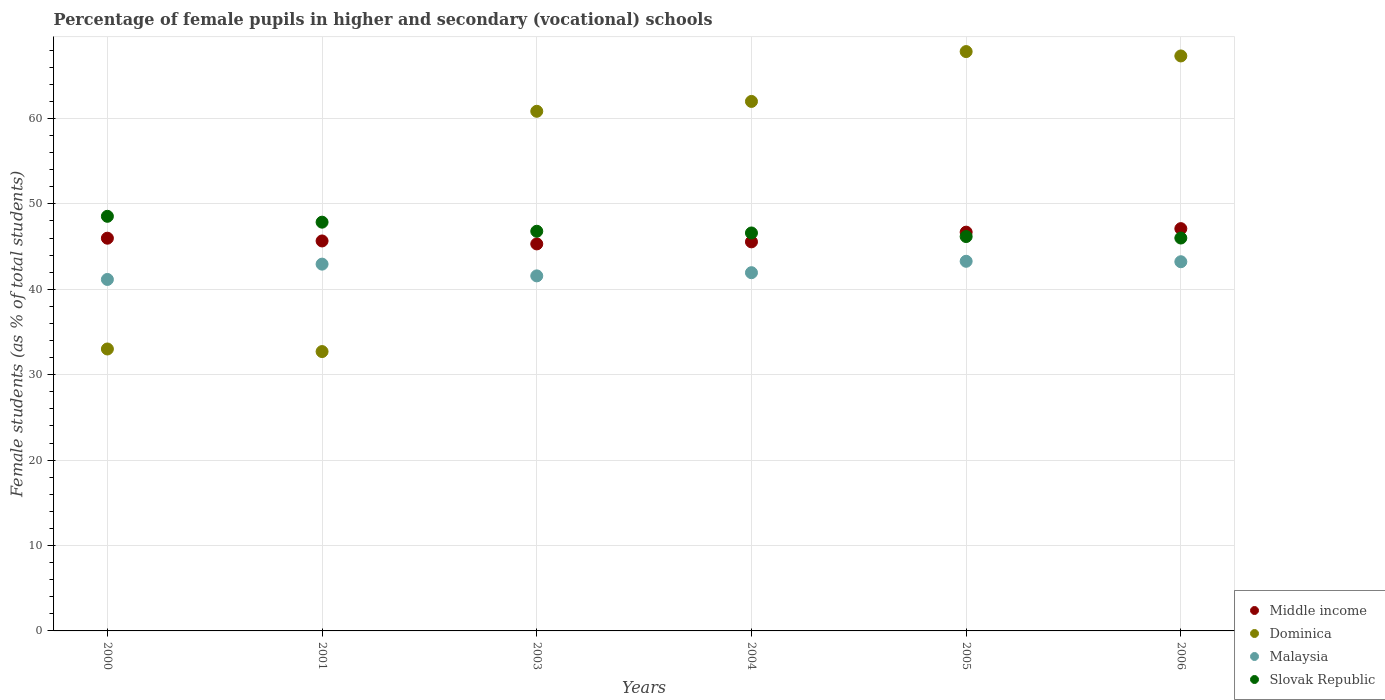How many different coloured dotlines are there?
Offer a very short reply. 4. Is the number of dotlines equal to the number of legend labels?
Your answer should be very brief. Yes. What is the percentage of female pupils in higher and secondary schools in Dominica in 2005?
Your answer should be compact. 67.83. Across all years, what is the maximum percentage of female pupils in higher and secondary schools in Slovak Republic?
Your answer should be compact. 48.54. Across all years, what is the minimum percentage of female pupils in higher and secondary schools in Slovak Republic?
Offer a terse response. 46. What is the total percentage of female pupils in higher and secondary schools in Dominica in the graph?
Your answer should be compact. 323.69. What is the difference between the percentage of female pupils in higher and secondary schools in Middle income in 2000 and that in 2003?
Your response must be concise. 0.67. What is the difference between the percentage of female pupils in higher and secondary schools in Slovak Republic in 2006 and the percentage of female pupils in higher and secondary schools in Malaysia in 2004?
Provide a short and direct response. 4.06. What is the average percentage of female pupils in higher and secondary schools in Middle income per year?
Your answer should be very brief. 46.05. In the year 2000, what is the difference between the percentage of female pupils in higher and secondary schools in Middle income and percentage of female pupils in higher and secondary schools in Malaysia?
Offer a terse response. 4.83. In how many years, is the percentage of female pupils in higher and secondary schools in Middle income greater than 66 %?
Your answer should be compact. 0. What is the ratio of the percentage of female pupils in higher and secondary schools in Dominica in 2005 to that in 2006?
Offer a very short reply. 1.01. Is the percentage of female pupils in higher and secondary schools in Middle income in 2001 less than that in 2003?
Offer a very short reply. No. Is the difference between the percentage of female pupils in higher and secondary schools in Middle income in 2003 and 2004 greater than the difference between the percentage of female pupils in higher and secondary schools in Malaysia in 2003 and 2004?
Your response must be concise. Yes. What is the difference between the highest and the second highest percentage of female pupils in higher and secondary schools in Dominica?
Your response must be concise. 0.51. What is the difference between the highest and the lowest percentage of female pupils in higher and secondary schools in Dominica?
Ensure brevity in your answer.  35.12. In how many years, is the percentage of female pupils in higher and secondary schools in Slovak Republic greater than the average percentage of female pupils in higher and secondary schools in Slovak Republic taken over all years?
Make the answer very short. 2. Is the percentage of female pupils in higher and secondary schools in Middle income strictly greater than the percentage of female pupils in higher and secondary schools in Slovak Republic over the years?
Offer a terse response. No. Is the percentage of female pupils in higher and secondary schools in Dominica strictly less than the percentage of female pupils in higher and secondary schools in Middle income over the years?
Your response must be concise. No. What is the difference between two consecutive major ticks on the Y-axis?
Give a very brief answer. 10. Are the values on the major ticks of Y-axis written in scientific E-notation?
Your answer should be compact. No. Does the graph contain any zero values?
Ensure brevity in your answer.  No. How are the legend labels stacked?
Your answer should be very brief. Vertical. What is the title of the graph?
Your response must be concise. Percentage of female pupils in higher and secondary (vocational) schools. What is the label or title of the Y-axis?
Offer a terse response. Female students (as % of total students). What is the Female students (as % of total students) in Middle income in 2000?
Ensure brevity in your answer.  45.98. What is the Female students (as % of total students) of Dominica in 2000?
Your answer should be compact. 33.01. What is the Female students (as % of total students) in Malaysia in 2000?
Give a very brief answer. 41.15. What is the Female students (as % of total students) of Slovak Republic in 2000?
Keep it short and to the point. 48.54. What is the Female students (as % of total students) of Middle income in 2001?
Your answer should be compact. 45.66. What is the Female students (as % of total students) of Dominica in 2001?
Ensure brevity in your answer.  32.71. What is the Female students (as % of total students) in Malaysia in 2001?
Provide a short and direct response. 42.94. What is the Female students (as % of total students) in Slovak Republic in 2001?
Provide a short and direct response. 47.86. What is the Female students (as % of total students) in Middle income in 2003?
Provide a short and direct response. 45.31. What is the Female students (as % of total students) in Dominica in 2003?
Provide a short and direct response. 60.84. What is the Female students (as % of total students) in Malaysia in 2003?
Offer a terse response. 41.57. What is the Female students (as % of total students) of Slovak Republic in 2003?
Your answer should be compact. 46.79. What is the Female students (as % of total students) in Middle income in 2004?
Offer a terse response. 45.55. What is the Female students (as % of total students) of Dominica in 2004?
Your answer should be very brief. 61.99. What is the Female students (as % of total students) in Malaysia in 2004?
Your answer should be very brief. 41.94. What is the Female students (as % of total students) in Slovak Republic in 2004?
Provide a short and direct response. 46.59. What is the Female students (as % of total students) of Middle income in 2005?
Keep it short and to the point. 46.69. What is the Female students (as % of total students) in Dominica in 2005?
Give a very brief answer. 67.83. What is the Female students (as % of total students) in Malaysia in 2005?
Provide a succinct answer. 43.28. What is the Female students (as % of total students) of Slovak Republic in 2005?
Provide a short and direct response. 46.17. What is the Female students (as % of total students) of Middle income in 2006?
Provide a short and direct response. 47.1. What is the Female students (as % of total students) in Dominica in 2006?
Provide a succinct answer. 67.32. What is the Female students (as % of total students) of Malaysia in 2006?
Provide a succinct answer. 43.22. What is the Female students (as % of total students) of Slovak Republic in 2006?
Give a very brief answer. 46. Across all years, what is the maximum Female students (as % of total students) of Middle income?
Provide a short and direct response. 47.1. Across all years, what is the maximum Female students (as % of total students) in Dominica?
Give a very brief answer. 67.83. Across all years, what is the maximum Female students (as % of total students) in Malaysia?
Your answer should be compact. 43.28. Across all years, what is the maximum Female students (as % of total students) in Slovak Republic?
Your response must be concise. 48.54. Across all years, what is the minimum Female students (as % of total students) of Middle income?
Offer a very short reply. 45.31. Across all years, what is the minimum Female students (as % of total students) in Dominica?
Give a very brief answer. 32.71. Across all years, what is the minimum Female students (as % of total students) in Malaysia?
Offer a very short reply. 41.15. Across all years, what is the minimum Female students (as % of total students) of Slovak Republic?
Make the answer very short. 46. What is the total Female students (as % of total students) of Middle income in the graph?
Keep it short and to the point. 276.29. What is the total Female students (as % of total students) in Dominica in the graph?
Your answer should be compact. 323.69. What is the total Female students (as % of total students) of Malaysia in the graph?
Make the answer very short. 254.1. What is the total Female students (as % of total students) of Slovak Republic in the graph?
Offer a terse response. 281.95. What is the difference between the Female students (as % of total students) of Middle income in 2000 and that in 2001?
Ensure brevity in your answer.  0.32. What is the difference between the Female students (as % of total students) of Dominica in 2000 and that in 2001?
Your answer should be compact. 0.3. What is the difference between the Female students (as % of total students) in Malaysia in 2000 and that in 2001?
Make the answer very short. -1.79. What is the difference between the Female students (as % of total students) of Slovak Republic in 2000 and that in 2001?
Make the answer very short. 0.69. What is the difference between the Female students (as % of total students) in Middle income in 2000 and that in 2003?
Give a very brief answer. 0.67. What is the difference between the Female students (as % of total students) of Dominica in 2000 and that in 2003?
Provide a succinct answer. -27.83. What is the difference between the Female students (as % of total students) of Malaysia in 2000 and that in 2003?
Ensure brevity in your answer.  -0.42. What is the difference between the Female students (as % of total students) of Slovak Republic in 2000 and that in 2003?
Provide a succinct answer. 1.75. What is the difference between the Female students (as % of total students) of Middle income in 2000 and that in 2004?
Make the answer very short. 0.43. What is the difference between the Female students (as % of total students) in Dominica in 2000 and that in 2004?
Make the answer very short. -28.98. What is the difference between the Female students (as % of total students) in Malaysia in 2000 and that in 2004?
Offer a very short reply. -0.79. What is the difference between the Female students (as % of total students) of Slovak Republic in 2000 and that in 2004?
Offer a terse response. 1.95. What is the difference between the Female students (as % of total students) in Middle income in 2000 and that in 2005?
Your response must be concise. -0.71. What is the difference between the Female students (as % of total students) of Dominica in 2000 and that in 2005?
Ensure brevity in your answer.  -34.82. What is the difference between the Female students (as % of total students) in Malaysia in 2000 and that in 2005?
Provide a succinct answer. -2.13. What is the difference between the Female students (as % of total students) of Slovak Republic in 2000 and that in 2005?
Your answer should be compact. 2.37. What is the difference between the Female students (as % of total students) of Middle income in 2000 and that in 2006?
Give a very brief answer. -1.12. What is the difference between the Female students (as % of total students) in Dominica in 2000 and that in 2006?
Offer a very short reply. -34.31. What is the difference between the Female students (as % of total students) in Malaysia in 2000 and that in 2006?
Offer a very short reply. -2.07. What is the difference between the Female students (as % of total students) in Slovak Republic in 2000 and that in 2006?
Offer a terse response. 2.54. What is the difference between the Female students (as % of total students) in Middle income in 2001 and that in 2003?
Provide a succinct answer. 0.35. What is the difference between the Female students (as % of total students) in Dominica in 2001 and that in 2003?
Offer a terse response. -28.13. What is the difference between the Female students (as % of total students) in Malaysia in 2001 and that in 2003?
Offer a terse response. 1.38. What is the difference between the Female students (as % of total students) in Slovak Republic in 2001 and that in 2003?
Provide a short and direct response. 1.06. What is the difference between the Female students (as % of total students) in Middle income in 2001 and that in 2004?
Provide a succinct answer. 0.11. What is the difference between the Female students (as % of total students) of Dominica in 2001 and that in 2004?
Ensure brevity in your answer.  -29.29. What is the difference between the Female students (as % of total students) in Malaysia in 2001 and that in 2004?
Your answer should be very brief. 1. What is the difference between the Female students (as % of total students) in Slovak Republic in 2001 and that in 2004?
Provide a short and direct response. 1.26. What is the difference between the Female students (as % of total students) of Middle income in 2001 and that in 2005?
Your response must be concise. -1.03. What is the difference between the Female students (as % of total students) of Dominica in 2001 and that in 2005?
Offer a terse response. -35.12. What is the difference between the Female students (as % of total students) in Malaysia in 2001 and that in 2005?
Your answer should be very brief. -0.33. What is the difference between the Female students (as % of total students) of Slovak Republic in 2001 and that in 2005?
Ensure brevity in your answer.  1.68. What is the difference between the Female students (as % of total students) of Middle income in 2001 and that in 2006?
Offer a very short reply. -1.44. What is the difference between the Female students (as % of total students) of Dominica in 2001 and that in 2006?
Give a very brief answer. -34.61. What is the difference between the Female students (as % of total students) in Malaysia in 2001 and that in 2006?
Offer a terse response. -0.28. What is the difference between the Female students (as % of total students) in Slovak Republic in 2001 and that in 2006?
Your answer should be compact. 1.86. What is the difference between the Female students (as % of total students) in Middle income in 2003 and that in 2004?
Keep it short and to the point. -0.24. What is the difference between the Female students (as % of total students) of Dominica in 2003 and that in 2004?
Make the answer very short. -1.16. What is the difference between the Female students (as % of total students) in Malaysia in 2003 and that in 2004?
Make the answer very short. -0.37. What is the difference between the Female students (as % of total students) of Slovak Republic in 2003 and that in 2004?
Your answer should be compact. 0.2. What is the difference between the Female students (as % of total students) in Middle income in 2003 and that in 2005?
Offer a very short reply. -1.38. What is the difference between the Female students (as % of total students) in Dominica in 2003 and that in 2005?
Provide a succinct answer. -6.99. What is the difference between the Female students (as % of total students) of Malaysia in 2003 and that in 2005?
Offer a very short reply. -1.71. What is the difference between the Female students (as % of total students) of Slovak Republic in 2003 and that in 2005?
Ensure brevity in your answer.  0.62. What is the difference between the Female students (as % of total students) in Middle income in 2003 and that in 2006?
Keep it short and to the point. -1.79. What is the difference between the Female students (as % of total students) in Dominica in 2003 and that in 2006?
Provide a succinct answer. -6.48. What is the difference between the Female students (as % of total students) in Malaysia in 2003 and that in 2006?
Offer a terse response. -1.66. What is the difference between the Female students (as % of total students) of Slovak Republic in 2003 and that in 2006?
Ensure brevity in your answer.  0.79. What is the difference between the Female students (as % of total students) in Middle income in 2004 and that in 2005?
Provide a short and direct response. -1.14. What is the difference between the Female students (as % of total students) in Dominica in 2004 and that in 2005?
Provide a short and direct response. -5.84. What is the difference between the Female students (as % of total students) of Malaysia in 2004 and that in 2005?
Provide a succinct answer. -1.34. What is the difference between the Female students (as % of total students) of Slovak Republic in 2004 and that in 2005?
Your answer should be very brief. 0.42. What is the difference between the Female students (as % of total students) of Middle income in 2004 and that in 2006?
Your answer should be compact. -1.55. What is the difference between the Female students (as % of total students) of Dominica in 2004 and that in 2006?
Provide a succinct answer. -5.32. What is the difference between the Female students (as % of total students) of Malaysia in 2004 and that in 2006?
Offer a terse response. -1.28. What is the difference between the Female students (as % of total students) in Slovak Republic in 2004 and that in 2006?
Your answer should be very brief. 0.59. What is the difference between the Female students (as % of total students) of Middle income in 2005 and that in 2006?
Provide a short and direct response. -0.41. What is the difference between the Female students (as % of total students) in Dominica in 2005 and that in 2006?
Make the answer very short. 0.51. What is the difference between the Female students (as % of total students) in Malaysia in 2005 and that in 2006?
Your answer should be very brief. 0.05. What is the difference between the Female students (as % of total students) of Slovak Republic in 2005 and that in 2006?
Your answer should be very brief. 0.17. What is the difference between the Female students (as % of total students) of Middle income in 2000 and the Female students (as % of total students) of Dominica in 2001?
Provide a short and direct response. 13.27. What is the difference between the Female students (as % of total students) in Middle income in 2000 and the Female students (as % of total students) in Malaysia in 2001?
Your answer should be very brief. 3.04. What is the difference between the Female students (as % of total students) in Middle income in 2000 and the Female students (as % of total students) in Slovak Republic in 2001?
Your response must be concise. -1.88. What is the difference between the Female students (as % of total students) of Dominica in 2000 and the Female students (as % of total students) of Malaysia in 2001?
Offer a terse response. -9.93. What is the difference between the Female students (as % of total students) in Dominica in 2000 and the Female students (as % of total students) in Slovak Republic in 2001?
Offer a terse response. -14.85. What is the difference between the Female students (as % of total students) in Malaysia in 2000 and the Female students (as % of total students) in Slovak Republic in 2001?
Your response must be concise. -6.71. What is the difference between the Female students (as % of total students) of Middle income in 2000 and the Female students (as % of total students) of Dominica in 2003?
Give a very brief answer. -14.86. What is the difference between the Female students (as % of total students) of Middle income in 2000 and the Female students (as % of total students) of Malaysia in 2003?
Offer a very short reply. 4.41. What is the difference between the Female students (as % of total students) of Middle income in 2000 and the Female students (as % of total students) of Slovak Republic in 2003?
Provide a succinct answer. -0.81. What is the difference between the Female students (as % of total students) of Dominica in 2000 and the Female students (as % of total students) of Malaysia in 2003?
Ensure brevity in your answer.  -8.56. What is the difference between the Female students (as % of total students) of Dominica in 2000 and the Female students (as % of total students) of Slovak Republic in 2003?
Ensure brevity in your answer.  -13.78. What is the difference between the Female students (as % of total students) in Malaysia in 2000 and the Female students (as % of total students) in Slovak Republic in 2003?
Your answer should be very brief. -5.64. What is the difference between the Female students (as % of total students) of Middle income in 2000 and the Female students (as % of total students) of Dominica in 2004?
Keep it short and to the point. -16.01. What is the difference between the Female students (as % of total students) in Middle income in 2000 and the Female students (as % of total students) in Malaysia in 2004?
Your response must be concise. 4.04. What is the difference between the Female students (as % of total students) of Middle income in 2000 and the Female students (as % of total students) of Slovak Republic in 2004?
Make the answer very short. -0.61. What is the difference between the Female students (as % of total students) in Dominica in 2000 and the Female students (as % of total students) in Malaysia in 2004?
Your response must be concise. -8.93. What is the difference between the Female students (as % of total students) in Dominica in 2000 and the Female students (as % of total students) in Slovak Republic in 2004?
Give a very brief answer. -13.58. What is the difference between the Female students (as % of total students) in Malaysia in 2000 and the Female students (as % of total students) in Slovak Republic in 2004?
Provide a short and direct response. -5.44. What is the difference between the Female students (as % of total students) of Middle income in 2000 and the Female students (as % of total students) of Dominica in 2005?
Your answer should be compact. -21.85. What is the difference between the Female students (as % of total students) of Middle income in 2000 and the Female students (as % of total students) of Malaysia in 2005?
Keep it short and to the point. 2.7. What is the difference between the Female students (as % of total students) of Middle income in 2000 and the Female students (as % of total students) of Slovak Republic in 2005?
Give a very brief answer. -0.19. What is the difference between the Female students (as % of total students) in Dominica in 2000 and the Female students (as % of total students) in Malaysia in 2005?
Your response must be concise. -10.27. What is the difference between the Female students (as % of total students) in Dominica in 2000 and the Female students (as % of total students) in Slovak Republic in 2005?
Offer a terse response. -13.16. What is the difference between the Female students (as % of total students) in Malaysia in 2000 and the Female students (as % of total students) in Slovak Republic in 2005?
Provide a succinct answer. -5.02. What is the difference between the Female students (as % of total students) in Middle income in 2000 and the Female students (as % of total students) in Dominica in 2006?
Keep it short and to the point. -21.34. What is the difference between the Female students (as % of total students) in Middle income in 2000 and the Female students (as % of total students) in Malaysia in 2006?
Your answer should be compact. 2.76. What is the difference between the Female students (as % of total students) in Middle income in 2000 and the Female students (as % of total students) in Slovak Republic in 2006?
Your answer should be very brief. -0.02. What is the difference between the Female students (as % of total students) in Dominica in 2000 and the Female students (as % of total students) in Malaysia in 2006?
Offer a very short reply. -10.22. What is the difference between the Female students (as % of total students) in Dominica in 2000 and the Female students (as % of total students) in Slovak Republic in 2006?
Ensure brevity in your answer.  -12.99. What is the difference between the Female students (as % of total students) in Malaysia in 2000 and the Female students (as % of total students) in Slovak Republic in 2006?
Give a very brief answer. -4.85. What is the difference between the Female students (as % of total students) of Middle income in 2001 and the Female students (as % of total students) of Dominica in 2003?
Provide a succinct answer. -15.18. What is the difference between the Female students (as % of total students) in Middle income in 2001 and the Female students (as % of total students) in Malaysia in 2003?
Offer a very short reply. 4.09. What is the difference between the Female students (as % of total students) of Middle income in 2001 and the Female students (as % of total students) of Slovak Republic in 2003?
Provide a succinct answer. -1.14. What is the difference between the Female students (as % of total students) in Dominica in 2001 and the Female students (as % of total students) in Malaysia in 2003?
Ensure brevity in your answer.  -8.86. What is the difference between the Female students (as % of total students) in Dominica in 2001 and the Female students (as % of total students) in Slovak Republic in 2003?
Offer a very short reply. -14.09. What is the difference between the Female students (as % of total students) in Malaysia in 2001 and the Female students (as % of total students) in Slovak Republic in 2003?
Ensure brevity in your answer.  -3.85. What is the difference between the Female students (as % of total students) in Middle income in 2001 and the Female students (as % of total students) in Dominica in 2004?
Keep it short and to the point. -16.34. What is the difference between the Female students (as % of total students) of Middle income in 2001 and the Female students (as % of total students) of Malaysia in 2004?
Your response must be concise. 3.72. What is the difference between the Female students (as % of total students) in Middle income in 2001 and the Female students (as % of total students) in Slovak Republic in 2004?
Keep it short and to the point. -0.94. What is the difference between the Female students (as % of total students) of Dominica in 2001 and the Female students (as % of total students) of Malaysia in 2004?
Offer a terse response. -9.23. What is the difference between the Female students (as % of total students) in Dominica in 2001 and the Female students (as % of total students) in Slovak Republic in 2004?
Provide a short and direct response. -13.89. What is the difference between the Female students (as % of total students) of Malaysia in 2001 and the Female students (as % of total students) of Slovak Republic in 2004?
Your answer should be compact. -3.65. What is the difference between the Female students (as % of total students) of Middle income in 2001 and the Female students (as % of total students) of Dominica in 2005?
Your answer should be compact. -22.17. What is the difference between the Female students (as % of total students) of Middle income in 2001 and the Female students (as % of total students) of Malaysia in 2005?
Your answer should be very brief. 2.38. What is the difference between the Female students (as % of total students) of Middle income in 2001 and the Female students (as % of total students) of Slovak Republic in 2005?
Keep it short and to the point. -0.51. What is the difference between the Female students (as % of total students) in Dominica in 2001 and the Female students (as % of total students) in Malaysia in 2005?
Your response must be concise. -10.57. What is the difference between the Female students (as % of total students) of Dominica in 2001 and the Female students (as % of total students) of Slovak Republic in 2005?
Keep it short and to the point. -13.47. What is the difference between the Female students (as % of total students) of Malaysia in 2001 and the Female students (as % of total students) of Slovak Republic in 2005?
Offer a terse response. -3.23. What is the difference between the Female students (as % of total students) of Middle income in 2001 and the Female students (as % of total students) of Dominica in 2006?
Provide a succinct answer. -21.66. What is the difference between the Female students (as % of total students) of Middle income in 2001 and the Female students (as % of total students) of Malaysia in 2006?
Provide a short and direct response. 2.43. What is the difference between the Female students (as % of total students) in Middle income in 2001 and the Female students (as % of total students) in Slovak Republic in 2006?
Give a very brief answer. -0.34. What is the difference between the Female students (as % of total students) of Dominica in 2001 and the Female students (as % of total students) of Malaysia in 2006?
Offer a very short reply. -10.52. What is the difference between the Female students (as % of total students) in Dominica in 2001 and the Female students (as % of total students) in Slovak Republic in 2006?
Make the answer very short. -13.29. What is the difference between the Female students (as % of total students) in Malaysia in 2001 and the Female students (as % of total students) in Slovak Republic in 2006?
Offer a very short reply. -3.06. What is the difference between the Female students (as % of total students) in Middle income in 2003 and the Female students (as % of total students) in Dominica in 2004?
Your answer should be very brief. -16.68. What is the difference between the Female students (as % of total students) of Middle income in 2003 and the Female students (as % of total students) of Malaysia in 2004?
Provide a short and direct response. 3.37. What is the difference between the Female students (as % of total students) in Middle income in 2003 and the Female students (as % of total students) in Slovak Republic in 2004?
Offer a very short reply. -1.28. What is the difference between the Female students (as % of total students) of Dominica in 2003 and the Female students (as % of total students) of Malaysia in 2004?
Make the answer very short. 18.9. What is the difference between the Female students (as % of total students) of Dominica in 2003 and the Female students (as % of total students) of Slovak Republic in 2004?
Make the answer very short. 14.25. What is the difference between the Female students (as % of total students) of Malaysia in 2003 and the Female students (as % of total students) of Slovak Republic in 2004?
Offer a very short reply. -5.02. What is the difference between the Female students (as % of total students) of Middle income in 2003 and the Female students (as % of total students) of Dominica in 2005?
Offer a very short reply. -22.52. What is the difference between the Female students (as % of total students) in Middle income in 2003 and the Female students (as % of total students) in Malaysia in 2005?
Offer a very short reply. 2.03. What is the difference between the Female students (as % of total students) of Middle income in 2003 and the Female students (as % of total students) of Slovak Republic in 2005?
Keep it short and to the point. -0.86. What is the difference between the Female students (as % of total students) of Dominica in 2003 and the Female students (as % of total students) of Malaysia in 2005?
Make the answer very short. 17.56. What is the difference between the Female students (as % of total students) of Dominica in 2003 and the Female students (as % of total students) of Slovak Republic in 2005?
Ensure brevity in your answer.  14.67. What is the difference between the Female students (as % of total students) of Malaysia in 2003 and the Female students (as % of total students) of Slovak Republic in 2005?
Your answer should be compact. -4.6. What is the difference between the Female students (as % of total students) in Middle income in 2003 and the Female students (as % of total students) in Dominica in 2006?
Provide a short and direct response. -22.01. What is the difference between the Female students (as % of total students) of Middle income in 2003 and the Female students (as % of total students) of Malaysia in 2006?
Make the answer very short. 2.09. What is the difference between the Female students (as % of total students) in Middle income in 2003 and the Female students (as % of total students) in Slovak Republic in 2006?
Provide a short and direct response. -0.69. What is the difference between the Female students (as % of total students) in Dominica in 2003 and the Female students (as % of total students) in Malaysia in 2006?
Ensure brevity in your answer.  17.61. What is the difference between the Female students (as % of total students) in Dominica in 2003 and the Female students (as % of total students) in Slovak Republic in 2006?
Your answer should be compact. 14.84. What is the difference between the Female students (as % of total students) in Malaysia in 2003 and the Female students (as % of total students) in Slovak Republic in 2006?
Ensure brevity in your answer.  -4.43. What is the difference between the Female students (as % of total students) in Middle income in 2004 and the Female students (as % of total students) in Dominica in 2005?
Make the answer very short. -22.28. What is the difference between the Female students (as % of total students) of Middle income in 2004 and the Female students (as % of total students) of Malaysia in 2005?
Give a very brief answer. 2.27. What is the difference between the Female students (as % of total students) of Middle income in 2004 and the Female students (as % of total students) of Slovak Republic in 2005?
Offer a terse response. -0.62. What is the difference between the Female students (as % of total students) of Dominica in 2004 and the Female students (as % of total students) of Malaysia in 2005?
Make the answer very short. 18.72. What is the difference between the Female students (as % of total students) in Dominica in 2004 and the Female students (as % of total students) in Slovak Republic in 2005?
Provide a succinct answer. 15.82. What is the difference between the Female students (as % of total students) of Malaysia in 2004 and the Female students (as % of total students) of Slovak Republic in 2005?
Make the answer very short. -4.23. What is the difference between the Female students (as % of total students) of Middle income in 2004 and the Female students (as % of total students) of Dominica in 2006?
Provide a short and direct response. -21.77. What is the difference between the Female students (as % of total students) in Middle income in 2004 and the Female students (as % of total students) in Malaysia in 2006?
Provide a succinct answer. 2.33. What is the difference between the Female students (as % of total students) of Middle income in 2004 and the Female students (as % of total students) of Slovak Republic in 2006?
Your response must be concise. -0.45. What is the difference between the Female students (as % of total students) of Dominica in 2004 and the Female students (as % of total students) of Malaysia in 2006?
Ensure brevity in your answer.  18.77. What is the difference between the Female students (as % of total students) in Dominica in 2004 and the Female students (as % of total students) in Slovak Republic in 2006?
Keep it short and to the point. 15.99. What is the difference between the Female students (as % of total students) in Malaysia in 2004 and the Female students (as % of total students) in Slovak Republic in 2006?
Your answer should be very brief. -4.06. What is the difference between the Female students (as % of total students) of Middle income in 2005 and the Female students (as % of total students) of Dominica in 2006?
Give a very brief answer. -20.63. What is the difference between the Female students (as % of total students) of Middle income in 2005 and the Female students (as % of total students) of Malaysia in 2006?
Your answer should be very brief. 3.46. What is the difference between the Female students (as % of total students) in Middle income in 2005 and the Female students (as % of total students) in Slovak Republic in 2006?
Provide a short and direct response. 0.69. What is the difference between the Female students (as % of total students) of Dominica in 2005 and the Female students (as % of total students) of Malaysia in 2006?
Make the answer very short. 24.61. What is the difference between the Female students (as % of total students) of Dominica in 2005 and the Female students (as % of total students) of Slovak Republic in 2006?
Offer a very short reply. 21.83. What is the difference between the Female students (as % of total students) in Malaysia in 2005 and the Female students (as % of total students) in Slovak Republic in 2006?
Ensure brevity in your answer.  -2.72. What is the average Female students (as % of total students) of Middle income per year?
Provide a short and direct response. 46.05. What is the average Female students (as % of total students) in Dominica per year?
Offer a very short reply. 53.95. What is the average Female students (as % of total students) in Malaysia per year?
Give a very brief answer. 42.35. What is the average Female students (as % of total students) of Slovak Republic per year?
Ensure brevity in your answer.  46.99. In the year 2000, what is the difference between the Female students (as % of total students) in Middle income and Female students (as % of total students) in Dominica?
Provide a succinct answer. 12.97. In the year 2000, what is the difference between the Female students (as % of total students) in Middle income and Female students (as % of total students) in Malaysia?
Make the answer very short. 4.83. In the year 2000, what is the difference between the Female students (as % of total students) in Middle income and Female students (as % of total students) in Slovak Republic?
Provide a succinct answer. -2.56. In the year 2000, what is the difference between the Female students (as % of total students) of Dominica and Female students (as % of total students) of Malaysia?
Provide a succinct answer. -8.14. In the year 2000, what is the difference between the Female students (as % of total students) in Dominica and Female students (as % of total students) in Slovak Republic?
Provide a succinct answer. -15.53. In the year 2000, what is the difference between the Female students (as % of total students) in Malaysia and Female students (as % of total students) in Slovak Republic?
Provide a succinct answer. -7.39. In the year 2001, what is the difference between the Female students (as % of total students) of Middle income and Female students (as % of total students) of Dominica?
Your answer should be very brief. 12.95. In the year 2001, what is the difference between the Female students (as % of total students) in Middle income and Female students (as % of total students) in Malaysia?
Provide a succinct answer. 2.71. In the year 2001, what is the difference between the Female students (as % of total students) in Middle income and Female students (as % of total students) in Slovak Republic?
Offer a very short reply. -2.2. In the year 2001, what is the difference between the Female students (as % of total students) of Dominica and Female students (as % of total students) of Malaysia?
Offer a very short reply. -10.24. In the year 2001, what is the difference between the Female students (as % of total students) in Dominica and Female students (as % of total students) in Slovak Republic?
Keep it short and to the point. -15.15. In the year 2001, what is the difference between the Female students (as % of total students) in Malaysia and Female students (as % of total students) in Slovak Republic?
Keep it short and to the point. -4.91. In the year 2003, what is the difference between the Female students (as % of total students) in Middle income and Female students (as % of total students) in Dominica?
Provide a succinct answer. -15.53. In the year 2003, what is the difference between the Female students (as % of total students) of Middle income and Female students (as % of total students) of Malaysia?
Your answer should be very brief. 3.74. In the year 2003, what is the difference between the Female students (as % of total students) in Middle income and Female students (as % of total students) in Slovak Republic?
Ensure brevity in your answer.  -1.48. In the year 2003, what is the difference between the Female students (as % of total students) of Dominica and Female students (as % of total students) of Malaysia?
Give a very brief answer. 19.27. In the year 2003, what is the difference between the Female students (as % of total students) of Dominica and Female students (as % of total students) of Slovak Republic?
Offer a very short reply. 14.05. In the year 2003, what is the difference between the Female students (as % of total students) in Malaysia and Female students (as % of total students) in Slovak Republic?
Offer a very short reply. -5.22. In the year 2004, what is the difference between the Female students (as % of total students) in Middle income and Female students (as % of total students) in Dominica?
Offer a terse response. -16.44. In the year 2004, what is the difference between the Female students (as % of total students) in Middle income and Female students (as % of total students) in Malaysia?
Make the answer very short. 3.61. In the year 2004, what is the difference between the Female students (as % of total students) of Middle income and Female students (as % of total students) of Slovak Republic?
Your answer should be compact. -1.04. In the year 2004, what is the difference between the Female students (as % of total students) of Dominica and Female students (as % of total students) of Malaysia?
Your answer should be very brief. 20.05. In the year 2004, what is the difference between the Female students (as % of total students) of Dominica and Female students (as % of total students) of Slovak Republic?
Make the answer very short. 15.4. In the year 2004, what is the difference between the Female students (as % of total students) of Malaysia and Female students (as % of total students) of Slovak Republic?
Provide a short and direct response. -4.65. In the year 2005, what is the difference between the Female students (as % of total students) in Middle income and Female students (as % of total students) in Dominica?
Ensure brevity in your answer.  -21.14. In the year 2005, what is the difference between the Female students (as % of total students) in Middle income and Female students (as % of total students) in Malaysia?
Your response must be concise. 3.41. In the year 2005, what is the difference between the Female students (as % of total students) of Middle income and Female students (as % of total students) of Slovak Republic?
Ensure brevity in your answer.  0.52. In the year 2005, what is the difference between the Female students (as % of total students) in Dominica and Female students (as % of total students) in Malaysia?
Provide a succinct answer. 24.55. In the year 2005, what is the difference between the Female students (as % of total students) of Dominica and Female students (as % of total students) of Slovak Republic?
Your answer should be very brief. 21.66. In the year 2005, what is the difference between the Female students (as % of total students) in Malaysia and Female students (as % of total students) in Slovak Republic?
Your answer should be compact. -2.9. In the year 2006, what is the difference between the Female students (as % of total students) of Middle income and Female students (as % of total students) of Dominica?
Give a very brief answer. -20.22. In the year 2006, what is the difference between the Female students (as % of total students) in Middle income and Female students (as % of total students) in Malaysia?
Provide a succinct answer. 3.88. In the year 2006, what is the difference between the Female students (as % of total students) in Middle income and Female students (as % of total students) in Slovak Republic?
Provide a short and direct response. 1.1. In the year 2006, what is the difference between the Female students (as % of total students) in Dominica and Female students (as % of total students) in Malaysia?
Your response must be concise. 24.09. In the year 2006, what is the difference between the Female students (as % of total students) of Dominica and Female students (as % of total students) of Slovak Republic?
Provide a succinct answer. 21.32. In the year 2006, what is the difference between the Female students (as % of total students) in Malaysia and Female students (as % of total students) in Slovak Republic?
Your answer should be compact. -2.78. What is the ratio of the Female students (as % of total students) of Middle income in 2000 to that in 2001?
Ensure brevity in your answer.  1.01. What is the ratio of the Female students (as % of total students) in Dominica in 2000 to that in 2001?
Make the answer very short. 1.01. What is the ratio of the Female students (as % of total students) in Malaysia in 2000 to that in 2001?
Your answer should be compact. 0.96. What is the ratio of the Female students (as % of total students) of Slovak Republic in 2000 to that in 2001?
Offer a very short reply. 1.01. What is the ratio of the Female students (as % of total students) in Middle income in 2000 to that in 2003?
Make the answer very short. 1.01. What is the ratio of the Female students (as % of total students) of Dominica in 2000 to that in 2003?
Give a very brief answer. 0.54. What is the ratio of the Female students (as % of total students) of Slovak Republic in 2000 to that in 2003?
Provide a succinct answer. 1.04. What is the ratio of the Female students (as % of total students) of Middle income in 2000 to that in 2004?
Ensure brevity in your answer.  1.01. What is the ratio of the Female students (as % of total students) in Dominica in 2000 to that in 2004?
Make the answer very short. 0.53. What is the ratio of the Female students (as % of total students) in Malaysia in 2000 to that in 2004?
Your response must be concise. 0.98. What is the ratio of the Female students (as % of total students) in Slovak Republic in 2000 to that in 2004?
Provide a short and direct response. 1.04. What is the ratio of the Female students (as % of total students) of Dominica in 2000 to that in 2005?
Offer a terse response. 0.49. What is the ratio of the Female students (as % of total students) in Malaysia in 2000 to that in 2005?
Offer a terse response. 0.95. What is the ratio of the Female students (as % of total students) of Slovak Republic in 2000 to that in 2005?
Offer a terse response. 1.05. What is the ratio of the Female students (as % of total students) of Middle income in 2000 to that in 2006?
Your answer should be very brief. 0.98. What is the ratio of the Female students (as % of total students) in Dominica in 2000 to that in 2006?
Provide a succinct answer. 0.49. What is the ratio of the Female students (as % of total students) in Malaysia in 2000 to that in 2006?
Give a very brief answer. 0.95. What is the ratio of the Female students (as % of total students) in Slovak Republic in 2000 to that in 2006?
Make the answer very short. 1.06. What is the ratio of the Female students (as % of total students) in Middle income in 2001 to that in 2003?
Your answer should be compact. 1.01. What is the ratio of the Female students (as % of total students) of Dominica in 2001 to that in 2003?
Give a very brief answer. 0.54. What is the ratio of the Female students (as % of total students) in Malaysia in 2001 to that in 2003?
Offer a terse response. 1.03. What is the ratio of the Female students (as % of total students) of Slovak Republic in 2001 to that in 2003?
Offer a very short reply. 1.02. What is the ratio of the Female students (as % of total students) in Dominica in 2001 to that in 2004?
Provide a succinct answer. 0.53. What is the ratio of the Female students (as % of total students) in Malaysia in 2001 to that in 2004?
Your answer should be very brief. 1.02. What is the ratio of the Female students (as % of total students) in Slovak Republic in 2001 to that in 2004?
Make the answer very short. 1.03. What is the ratio of the Female students (as % of total students) of Middle income in 2001 to that in 2005?
Your answer should be compact. 0.98. What is the ratio of the Female students (as % of total students) in Dominica in 2001 to that in 2005?
Ensure brevity in your answer.  0.48. What is the ratio of the Female students (as % of total students) of Slovak Republic in 2001 to that in 2005?
Give a very brief answer. 1.04. What is the ratio of the Female students (as % of total students) of Middle income in 2001 to that in 2006?
Provide a succinct answer. 0.97. What is the ratio of the Female students (as % of total students) of Dominica in 2001 to that in 2006?
Your response must be concise. 0.49. What is the ratio of the Female students (as % of total students) in Malaysia in 2001 to that in 2006?
Provide a short and direct response. 0.99. What is the ratio of the Female students (as % of total students) of Slovak Republic in 2001 to that in 2006?
Offer a very short reply. 1.04. What is the ratio of the Female students (as % of total students) in Middle income in 2003 to that in 2004?
Your response must be concise. 0.99. What is the ratio of the Female students (as % of total students) in Dominica in 2003 to that in 2004?
Your answer should be very brief. 0.98. What is the ratio of the Female students (as % of total students) in Middle income in 2003 to that in 2005?
Your answer should be compact. 0.97. What is the ratio of the Female students (as % of total students) in Dominica in 2003 to that in 2005?
Give a very brief answer. 0.9. What is the ratio of the Female students (as % of total students) of Malaysia in 2003 to that in 2005?
Your answer should be compact. 0.96. What is the ratio of the Female students (as % of total students) of Slovak Republic in 2003 to that in 2005?
Offer a very short reply. 1.01. What is the ratio of the Female students (as % of total students) in Dominica in 2003 to that in 2006?
Provide a short and direct response. 0.9. What is the ratio of the Female students (as % of total students) in Malaysia in 2003 to that in 2006?
Offer a very short reply. 0.96. What is the ratio of the Female students (as % of total students) of Slovak Republic in 2003 to that in 2006?
Provide a succinct answer. 1.02. What is the ratio of the Female students (as % of total students) in Middle income in 2004 to that in 2005?
Make the answer very short. 0.98. What is the ratio of the Female students (as % of total students) in Dominica in 2004 to that in 2005?
Keep it short and to the point. 0.91. What is the ratio of the Female students (as % of total students) of Malaysia in 2004 to that in 2005?
Your answer should be compact. 0.97. What is the ratio of the Female students (as % of total students) in Slovak Republic in 2004 to that in 2005?
Offer a terse response. 1.01. What is the ratio of the Female students (as % of total students) of Middle income in 2004 to that in 2006?
Give a very brief answer. 0.97. What is the ratio of the Female students (as % of total students) in Dominica in 2004 to that in 2006?
Your answer should be compact. 0.92. What is the ratio of the Female students (as % of total students) in Malaysia in 2004 to that in 2006?
Your answer should be very brief. 0.97. What is the ratio of the Female students (as % of total students) of Slovak Republic in 2004 to that in 2006?
Offer a very short reply. 1.01. What is the ratio of the Female students (as % of total students) of Middle income in 2005 to that in 2006?
Keep it short and to the point. 0.99. What is the ratio of the Female students (as % of total students) in Dominica in 2005 to that in 2006?
Your response must be concise. 1.01. What is the ratio of the Female students (as % of total students) in Malaysia in 2005 to that in 2006?
Keep it short and to the point. 1. What is the difference between the highest and the second highest Female students (as % of total students) in Middle income?
Your answer should be compact. 0.41. What is the difference between the highest and the second highest Female students (as % of total students) in Dominica?
Offer a very short reply. 0.51. What is the difference between the highest and the second highest Female students (as % of total students) of Malaysia?
Ensure brevity in your answer.  0.05. What is the difference between the highest and the second highest Female students (as % of total students) of Slovak Republic?
Give a very brief answer. 0.69. What is the difference between the highest and the lowest Female students (as % of total students) in Middle income?
Your response must be concise. 1.79. What is the difference between the highest and the lowest Female students (as % of total students) in Dominica?
Make the answer very short. 35.12. What is the difference between the highest and the lowest Female students (as % of total students) in Malaysia?
Provide a succinct answer. 2.13. What is the difference between the highest and the lowest Female students (as % of total students) of Slovak Republic?
Offer a very short reply. 2.54. 